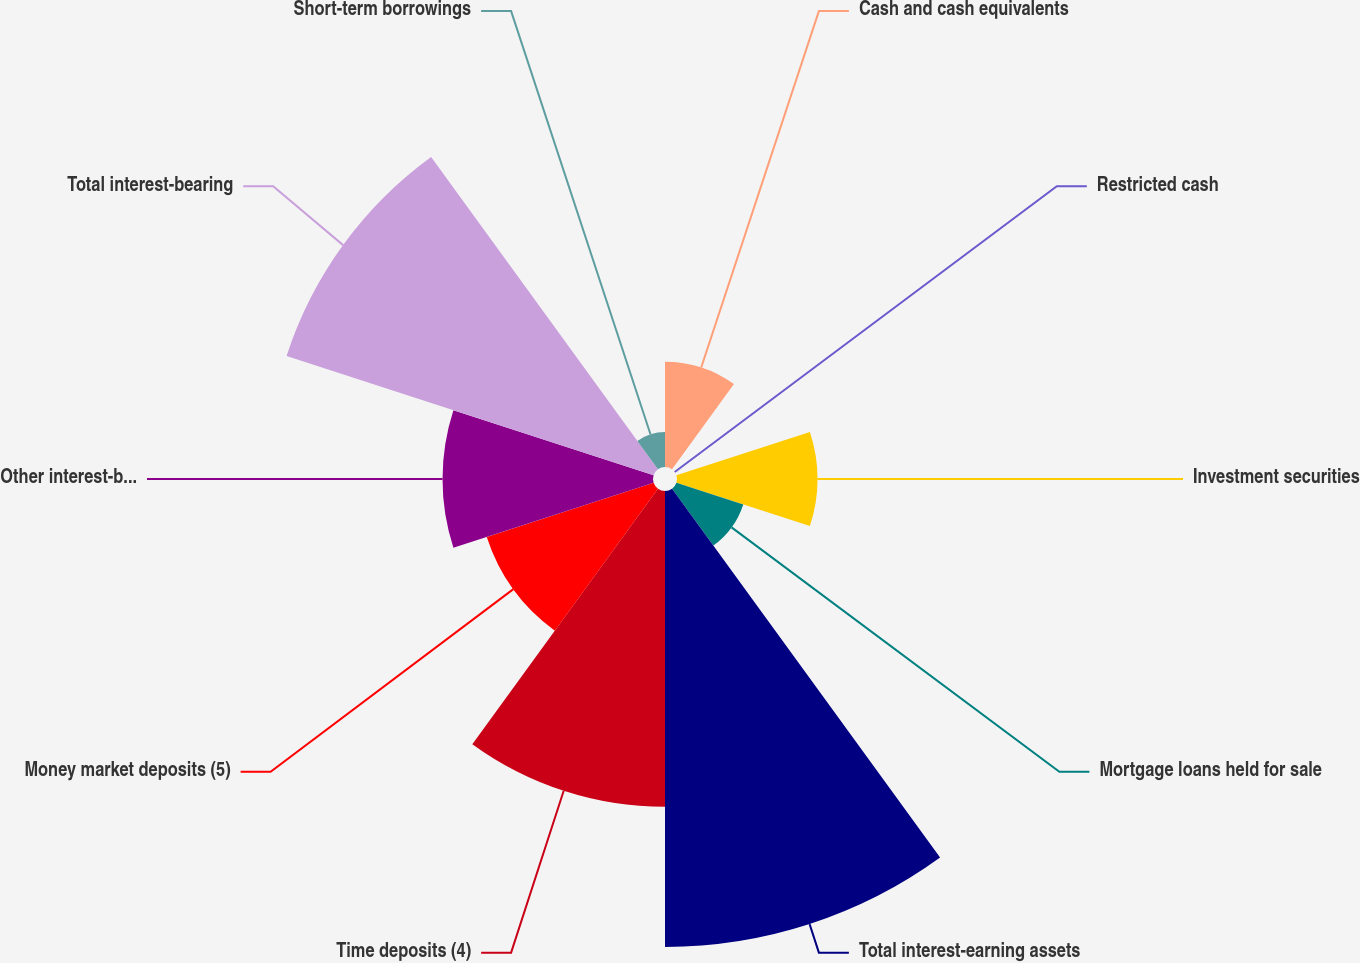Convert chart. <chart><loc_0><loc_0><loc_500><loc_500><pie_chart><fcel>Cash and cash equivalents<fcel>Restricted cash<fcel>Investment securities<fcel>Mortgage loans held for sale<fcel>Total interest-earning assets<fcel>Time deposits (4)<fcel>Money market deposits (5)<fcel>Other interest-bearing savings<fcel>Total interest-bearing<fcel>Short-term borrowings<nl><fcel>5.56%<fcel>0.0%<fcel>7.41%<fcel>3.71%<fcel>24.07%<fcel>16.67%<fcel>9.26%<fcel>11.11%<fcel>20.37%<fcel>1.85%<nl></chart> 